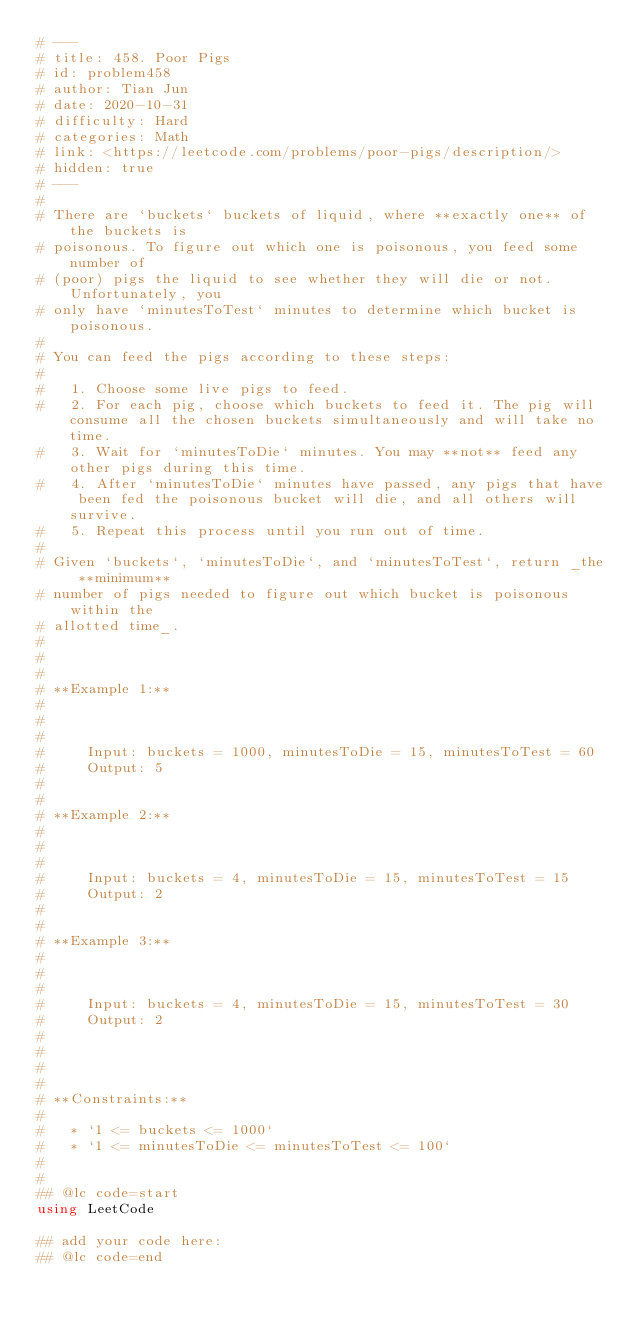Convert code to text. <code><loc_0><loc_0><loc_500><loc_500><_Julia_># ---
# title: 458. Poor Pigs
# id: problem458
# author: Tian Jun
# date: 2020-10-31
# difficulty: Hard
# categories: Math
# link: <https://leetcode.com/problems/poor-pigs/description/>
# hidden: true
# ---
# 
# There are `buckets` buckets of liquid, where **exactly one** of the buckets is
# poisonous. To figure out which one is poisonous, you feed some number of
# (poor) pigs the liquid to see whether they will die or not. Unfortunately, you
# only have `minutesToTest` minutes to determine which bucket is poisonous.
# 
# You can feed the pigs according to these steps:
# 
#   1. Choose some live pigs to feed.
#   2. For each pig, choose which buckets to feed it. The pig will consume all the chosen buckets simultaneously and will take no time.
#   3. Wait for `minutesToDie` minutes. You may **not** feed any other pigs during this time.
#   4. After `minutesToDie` minutes have passed, any pigs that have been fed the poisonous bucket will die, and all others will survive.
#   5. Repeat this process until you run out of time.
# 
# Given `buckets`, `minutesToDie`, and `minutesToTest`, return _the **minimum**
# number of pigs needed to figure out which bucket is poisonous within the
# allotted time_.
# 
# 
# 
# **Example 1:**
# 
#     
#     
#     Input: buckets = 1000, minutesToDie = 15, minutesToTest = 60
#     Output: 5
#     
# 
# **Example 2:**
# 
#     
#     
#     Input: buckets = 4, minutesToDie = 15, minutesToTest = 15
#     Output: 2
#     
# 
# **Example 3:**
# 
#     
#     
#     Input: buckets = 4, minutesToDie = 15, minutesToTest = 30
#     Output: 2
#     
# 
# 
# 
# **Constraints:**
# 
#   * `1 <= buckets <= 1000`
#   * `1 <= minutesToDie <= minutesToTest <= 100`
# 
# 
## @lc code=start
using LeetCode

## add your code here:
## @lc code=end
</code> 